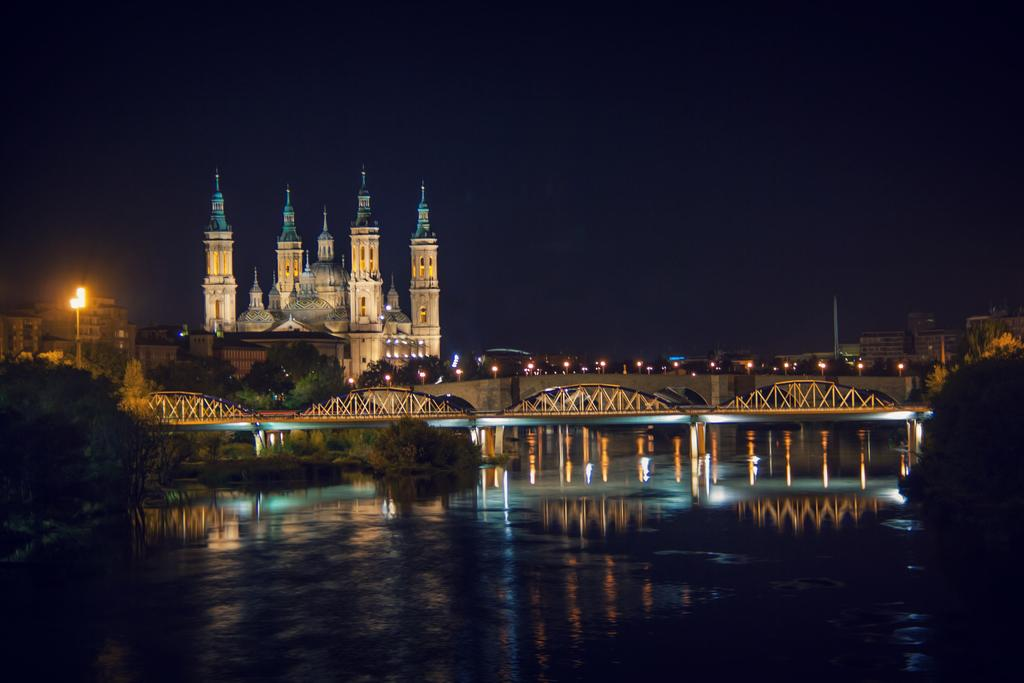What type of natural elements can be seen in the image? There are trees in the image. What type of man-made structure is present in the image? There is a bridge in the image. What other man-made structures can be seen in the image? There are buildings in the image. What type of illumination is present in the image? There are lights in the image. What type of natural feature is visible in the image? There is water visible in the image. What part of the natural environment is visible in the image? The sky is visible in the image. What type of vest is being worn by the clock in the image? There is no clock or vest present in the image. How does the image demonstrate respect for the environment? The image does not demonstrate respect for the environment; it is a visual representation of a scene that includes trees, a bridge, buildings, lights, water, and the sky. 